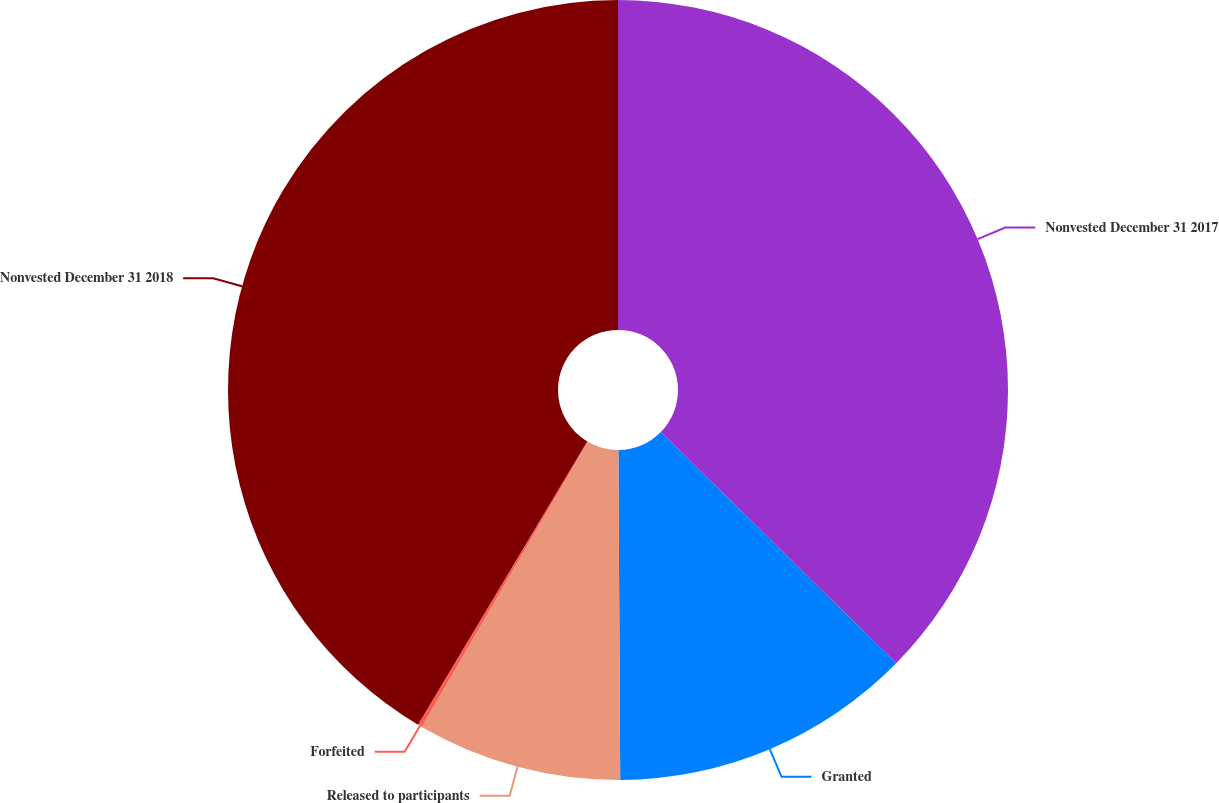<chart> <loc_0><loc_0><loc_500><loc_500><pie_chart><fcel>Nonvested December 31 2017<fcel>Granted<fcel>Released to participants<fcel>Forfeited<fcel>Nonvested December 31 2018<nl><fcel>37.36%<fcel>12.55%<fcel>8.48%<fcel>0.18%<fcel>41.43%<nl></chart> 